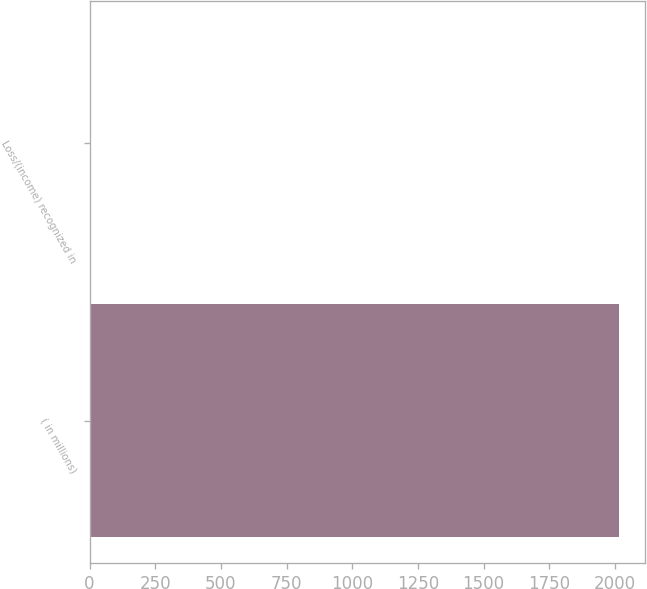<chart> <loc_0><loc_0><loc_500><loc_500><bar_chart><fcel>( in millions)<fcel>Loss/(income) recognized in<nl><fcel>2015<fcel>2<nl></chart> 